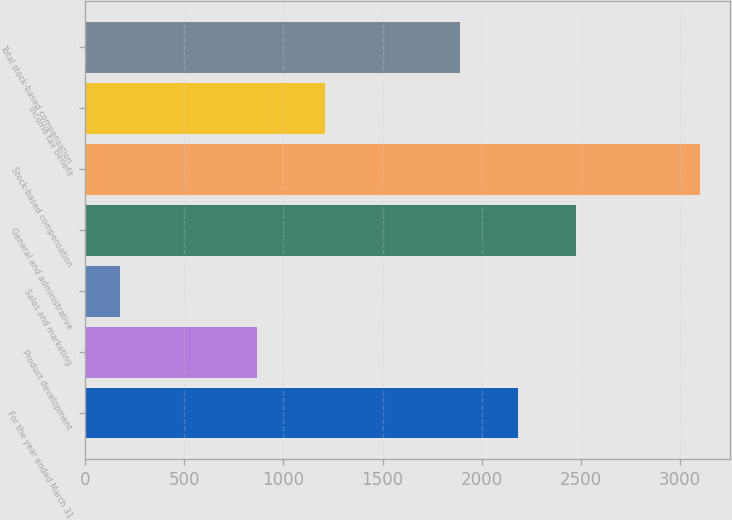Convert chart to OTSL. <chart><loc_0><loc_0><loc_500><loc_500><bar_chart><fcel>For the year ended March 31<fcel>Product development<fcel>Sales and marketing<fcel>General and administrative<fcel>Stock-based compensation<fcel>Income tax benefit<fcel>Total stock-based compensation<nl><fcel>2183.4<fcel>869<fcel>175<fcel>2475.8<fcel>3099<fcel>1208<fcel>1891<nl></chart> 